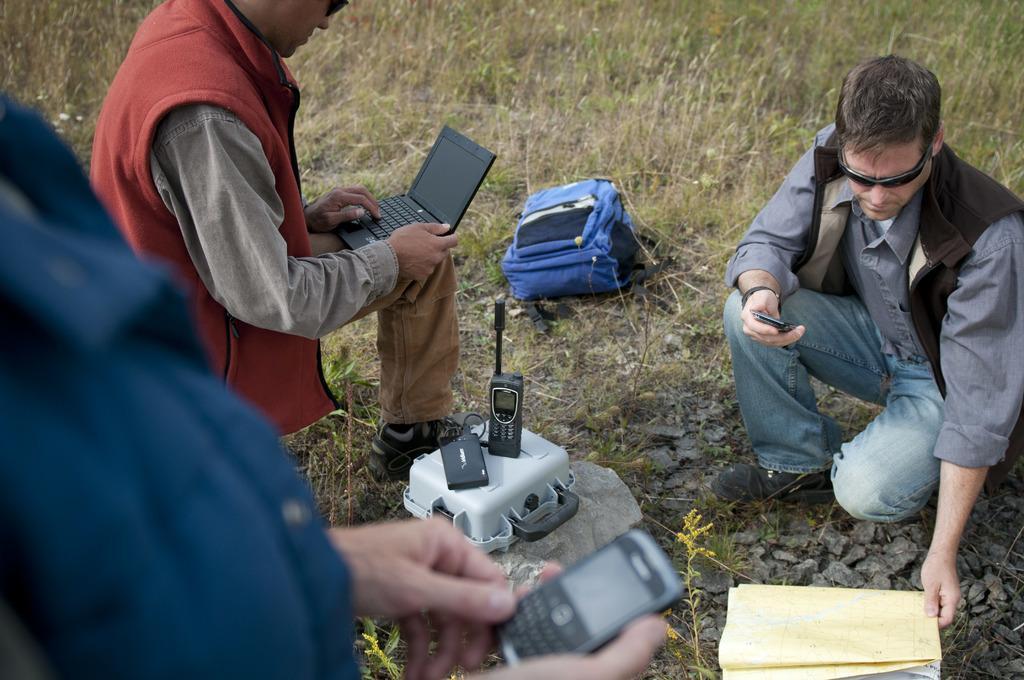How would you summarize this image in a sentence or two? In the picture we can see a grass surface with a man sitting on it and holding a mobile phone and with the other hand he is holding some papers and besides to him we can see another man sitting and holding a laptop and working and besides him we can see another person standing and holding a mobile phone and on the grass surface we can see a charger box with phone and beside it we can see a bag which is blue in color. 